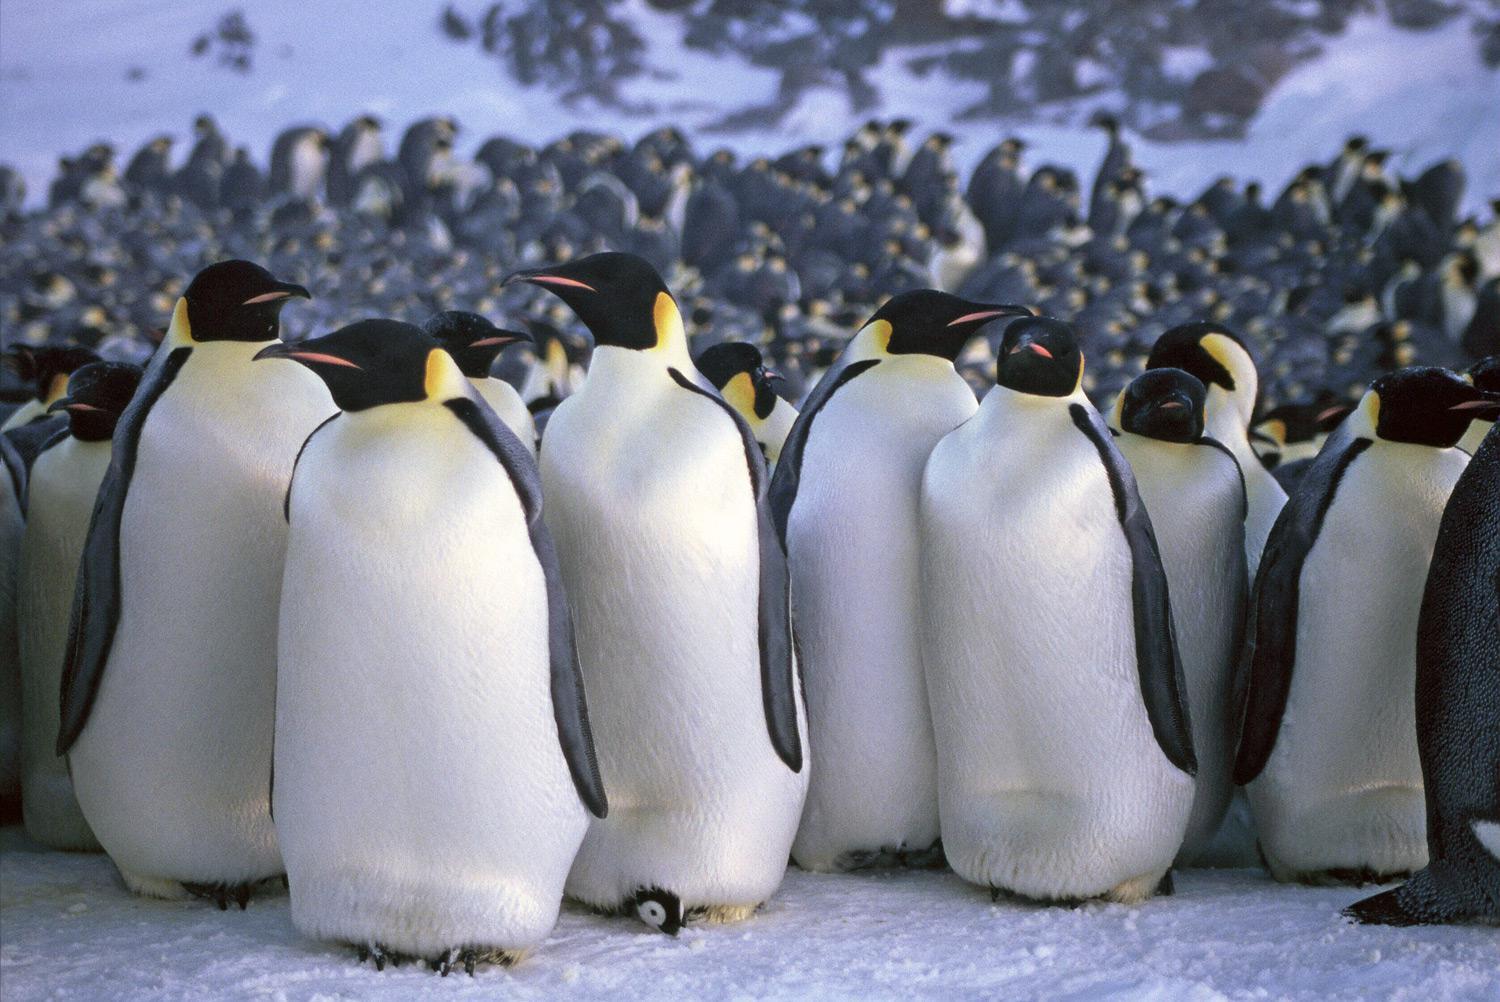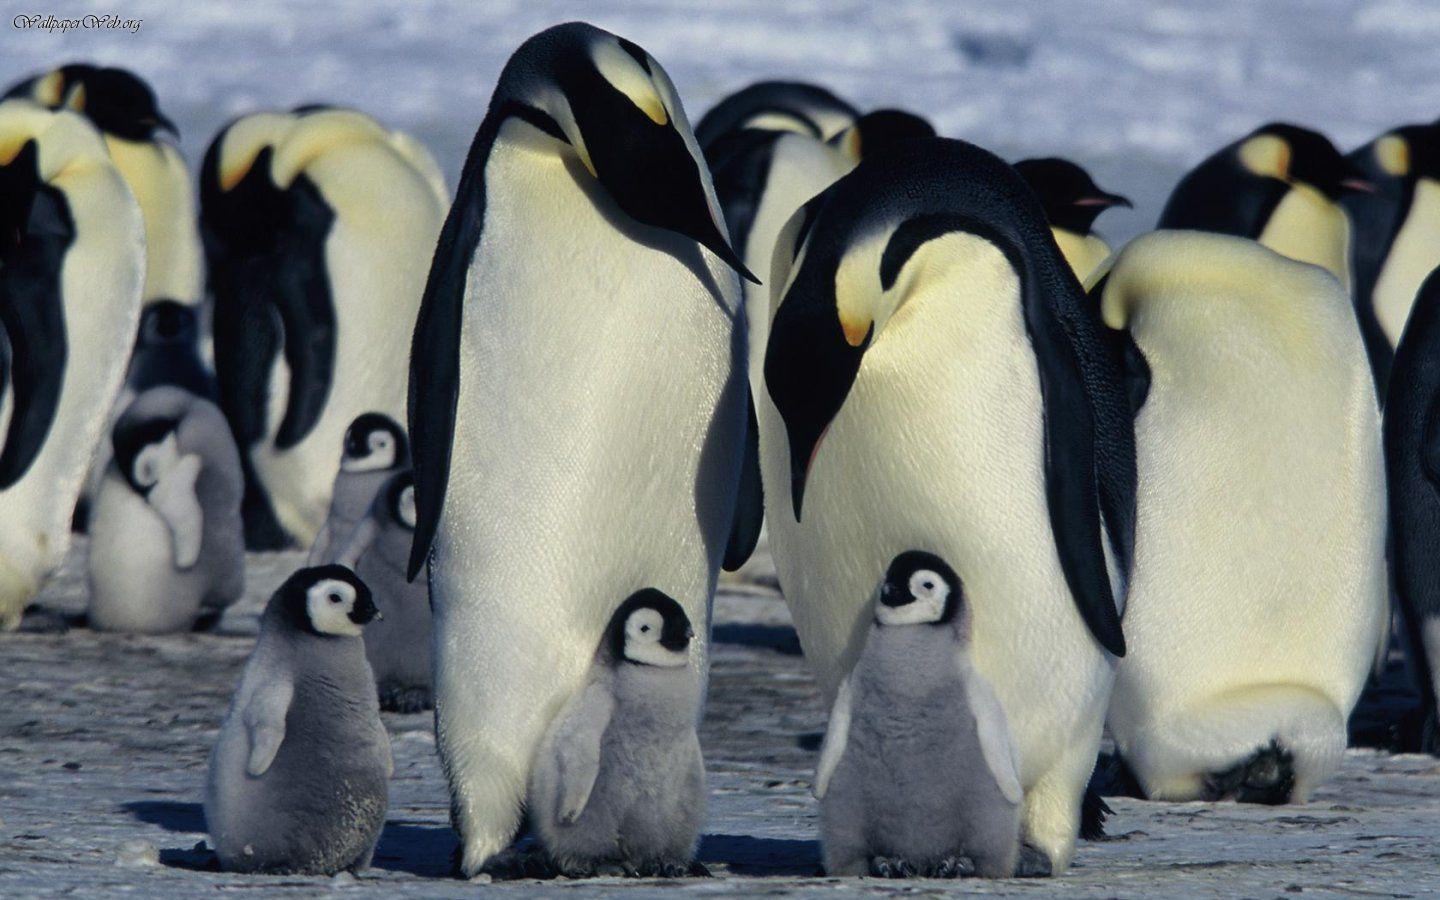The first image is the image on the left, the second image is the image on the right. Examine the images to the left and right. Is the description "In the left image, there are two adult penguins and one baby penguin" accurate? Answer yes or no. No. The first image is the image on the left, the second image is the image on the right. Analyze the images presented: Is the assertion "One image shows only one penguin family, with parents flanking a baby." valid? Answer yes or no. No. 